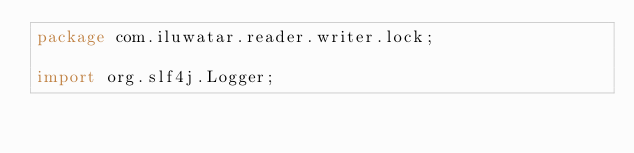Convert code to text. <code><loc_0><loc_0><loc_500><loc_500><_Java_>package com.iluwatar.reader.writer.lock;

import org.slf4j.Logger;</code> 